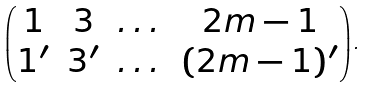<formula> <loc_0><loc_0><loc_500><loc_500>\begin{pmatrix} 1 & 3 & \dots & 2 m - 1 \\ 1 ^ { \prime } & 3 ^ { \prime } & \dots & ( 2 m - 1 ) ^ { \prime } \end{pmatrix} .</formula> 